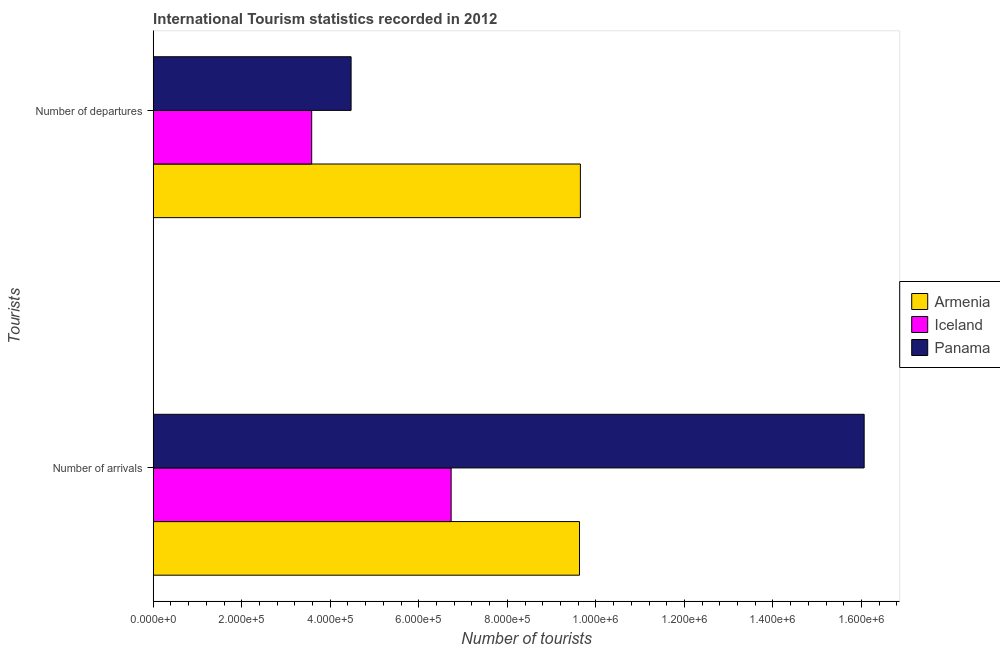How many groups of bars are there?
Make the answer very short. 2. Are the number of bars per tick equal to the number of legend labels?
Your answer should be very brief. Yes. Are the number of bars on each tick of the Y-axis equal?
Offer a very short reply. Yes. How many bars are there on the 2nd tick from the top?
Make the answer very short. 3. How many bars are there on the 2nd tick from the bottom?
Keep it short and to the point. 3. What is the label of the 2nd group of bars from the top?
Your answer should be very brief. Number of arrivals. What is the number of tourist departures in Armenia?
Make the answer very short. 9.65e+05. Across all countries, what is the maximum number of tourist arrivals?
Provide a short and direct response. 1.61e+06. Across all countries, what is the minimum number of tourist arrivals?
Give a very brief answer. 6.73e+05. In which country was the number of tourist departures maximum?
Provide a succinct answer. Armenia. In which country was the number of tourist departures minimum?
Your response must be concise. Iceland. What is the total number of tourist departures in the graph?
Provide a short and direct response. 1.77e+06. What is the difference between the number of tourist departures in Armenia and that in Iceland?
Ensure brevity in your answer.  6.07e+05. What is the difference between the number of tourist arrivals in Iceland and the number of tourist departures in Armenia?
Provide a short and direct response. -2.92e+05. What is the average number of tourist arrivals per country?
Your answer should be very brief. 1.08e+06. What is the difference between the number of tourist arrivals and number of tourist departures in Panama?
Make the answer very short. 1.16e+06. What is the ratio of the number of tourist arrivals in Panama to that in Armenia?
Your answer should be compact. 1.67. In how many countries, is the number of tourist departures greater than the average number of tourist departures taken over all countries?
Provide a succinct answer. 1. What does the 1st bar from the bottom in Number of arrivals represents?
Your answer should be very brief. Armenia. How many countries are there in the graph?
Offer a very short reply. 3. Does the graph contain grids?
Give a very brief answer. No. Where does the legend appear in the graph?
Give a very brief answer. Center right. What is the title of the graph?
Your answer should be very brief. International Tourism statistics recorded in 2012. Does "Seychelles" appear as one of the legend labels in the graph?
Your answer should be compact. No. What is the label or title of the X-axis?
Make the answer very short. Number of tourists. What is the label or title of the Y-axis?
Your answer should be compact. Tourists. What is the Number of tourists in Armenia in Number of arrivals?
Your answer should be compact. 9.63e+05. What is the Number of tourists in Iceland in Number of arrivals?
Provide a succinct answer. 6.73e+05. What is the Number of tourists in Panama in Number of arrivals?
Offer a very short reply. 1.61e+06. What is the Number of tourists in Armenia in Number of departures?
Your answer should be very brief. 9.65e+05. What is the Number of tourists of Iceland in Number of departures?
Provide a short and direct response. 3.58e+05. What is the Number of tourists of Panama in Number of departures?
Your answer should be compact. 4.47e+05. Across all Tourists, what is the maximum Number of tourists in Armenia?
Your answer should be very brief. 9.65e+05. Across all Tourists, what is the maximum Number of tourists of Iceland?
Your answer should be compact. 6.73e+05. Across all Tourists, what is the maximum Number of tourists of Panama?
Provide a succinct answer. 1.61e+06. Across all Tourists, what is the minimum Number of tourists in Armenia?
Make the answer very short. 9.63e+05. Across all Tourists, what is the minimum Number of tourists of Iceland?
Provide a short and direct response. 3.58e+05. Across all Tourists, what is the minimum Number of tourists in Panama?
Give a very brief answer. 4.47e+05. What is the total Number of tourists of Armenia in the graph?
Keep it short and to the point. 1.93e+06. What is the total Number of tourists in Iceland in the graph?
Offer a terse response. 1.03e+06. What is the total Number of tourists in Panama in the graph?
Provide a succinct answer. 2.05e+06. What is the difference between the Number of tourists in Armenia in Number of arrivals and that in Number of departures?
Offer a very short reply. -2000. What is the difference between the Number of tourists of Iceland in Number of arrivals and that in Number of departures?
Offer a very short reply. 3.15e+05. What is the difference between the Number of tourists of Panama in Number of arrivals and that in Number of departures?
Provide a short and direct response. 1.16e+06. What is the difference between the Number of tourists of Armenia in Number of arrivals and the Number of tourists of Iceland in Number of departures?
Make the answer very short. 6.05e+05. What is the difference between the Number of tourists of Armenia in Number of arrivals and the Number of tourists of Panama in Number of departures?
Keep it short and to the point. 5.16e+05. What is the difference between the Number of tourists in Iceland in Number of arrivals and the Number of tourists in Panama in Number of departures?
Your response must be concise. 2.26e+05. What is the average Number of tourists of Armenia per Tourists?
Ensure brevity in your answer.  9.64e+05. What is the average Number of tourists of Iceland per Tourists?
Ensure brevity in your answer.  5.16e+05. What is the average Number of tourists in Panama per Tourists?
Give a very brief answer. 1.03e+06. What is the difference between the Number of tourists in Armenia and Number of tourists in Iceland in Number of arrivals?
Your response must be concise. 2.90e+05. What is the difference between the Number of tourists of Armenia and Number of tourists of Panama in Number of arrivals?
Make the answer very short. -6.43e+05. What is the difference between the Number of tourists in Iceland and Number of tourists in Panama in Number of arrivals?
Ensure brevity in your answer.  -9.33e+05. What is the difference between the Number of tourists in Armenia and Number of tourists in Iceland in Number of departures?
Provide a short and direct response. 6.07e+05. What is the difference between the Number of tourists in Armenia and Number of tourists in Panama in Number of departures?
Ensure brevity in your answer.  5.18e+05. What is the difference between the Number of tourists in Iceland and Number of tourists in Panama in Number of departures?
Make the answer very short. -8.90e+04. What is the ratio of the Number of tourists in Armenia in Number of arrivals to that in Number of departures?
Ensure brevity in your answer.  1. What is the ratio of the Number of tourists of Iceland in Number of arrivals to that in Number of departures?
Give a very brief answer. 1.88. What is the ratio of the Number of tourists in Panama in Number of arrivals to that in Number of departures?
Your answer should be compact. 3.59. What is the difference between the highest and the second highest Number of tourists of Armenia?
Your response must be concise. 2000. What is the difference between the highest and the second highest Number of tourists of Iceland?
Make the answer very short. 3.15e+05. What is the difference between the highest and the second highest Number of tourists of Panama?
Your answer should be very brief. 1.16e+06. What is the difference between the highest and the lowest Number of tourists of Armenia?
Give a very brief answer. 2000. What is the difference between the highest and the lowest Number of tourists in Iceland?
Offer a terse response. 3.15e+05. What is the difference between the highest and the lowest Number of tourists of Panama?
Provide a succinct answer. 1.16e+06. 